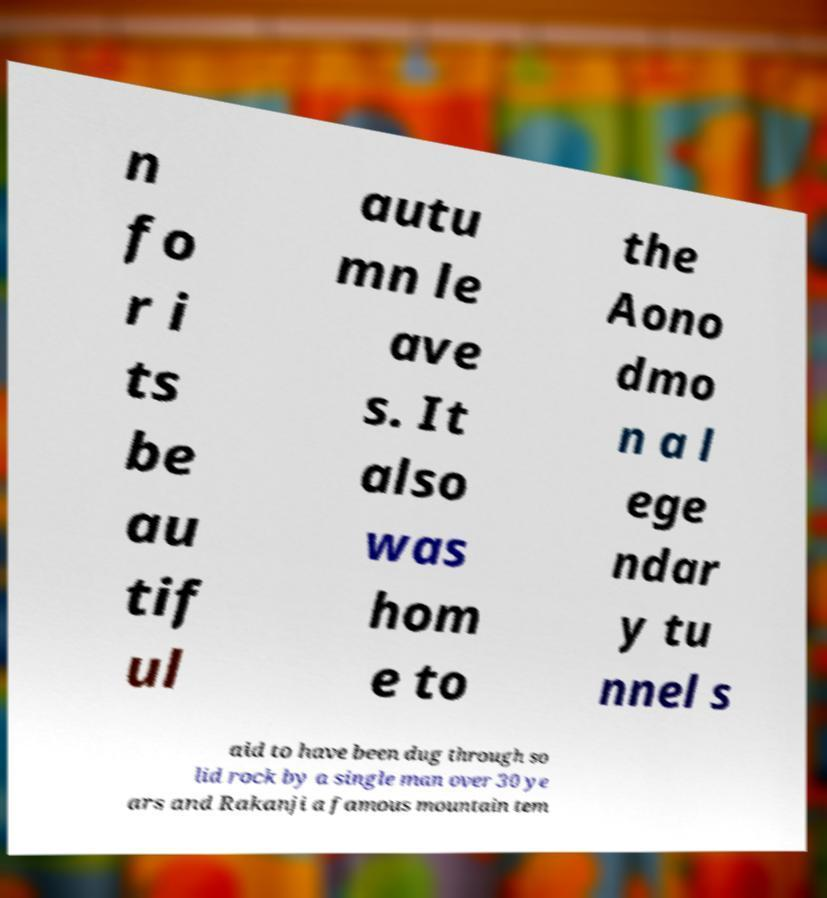Please read and relay the text visible in this image. What does it say? n fo r i ts be au tif ul autu mn le ave s. It also was hom e to the Aono dmo n a l ege ndar y tu nnel s aid to have been dug through so lid rock by a single man over 30 ye ars and Rakanji a famous mountain tem 